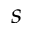Convert formula to latex. <formula><loc_0><loc_0><loc_500><loc_500>s</formula> 